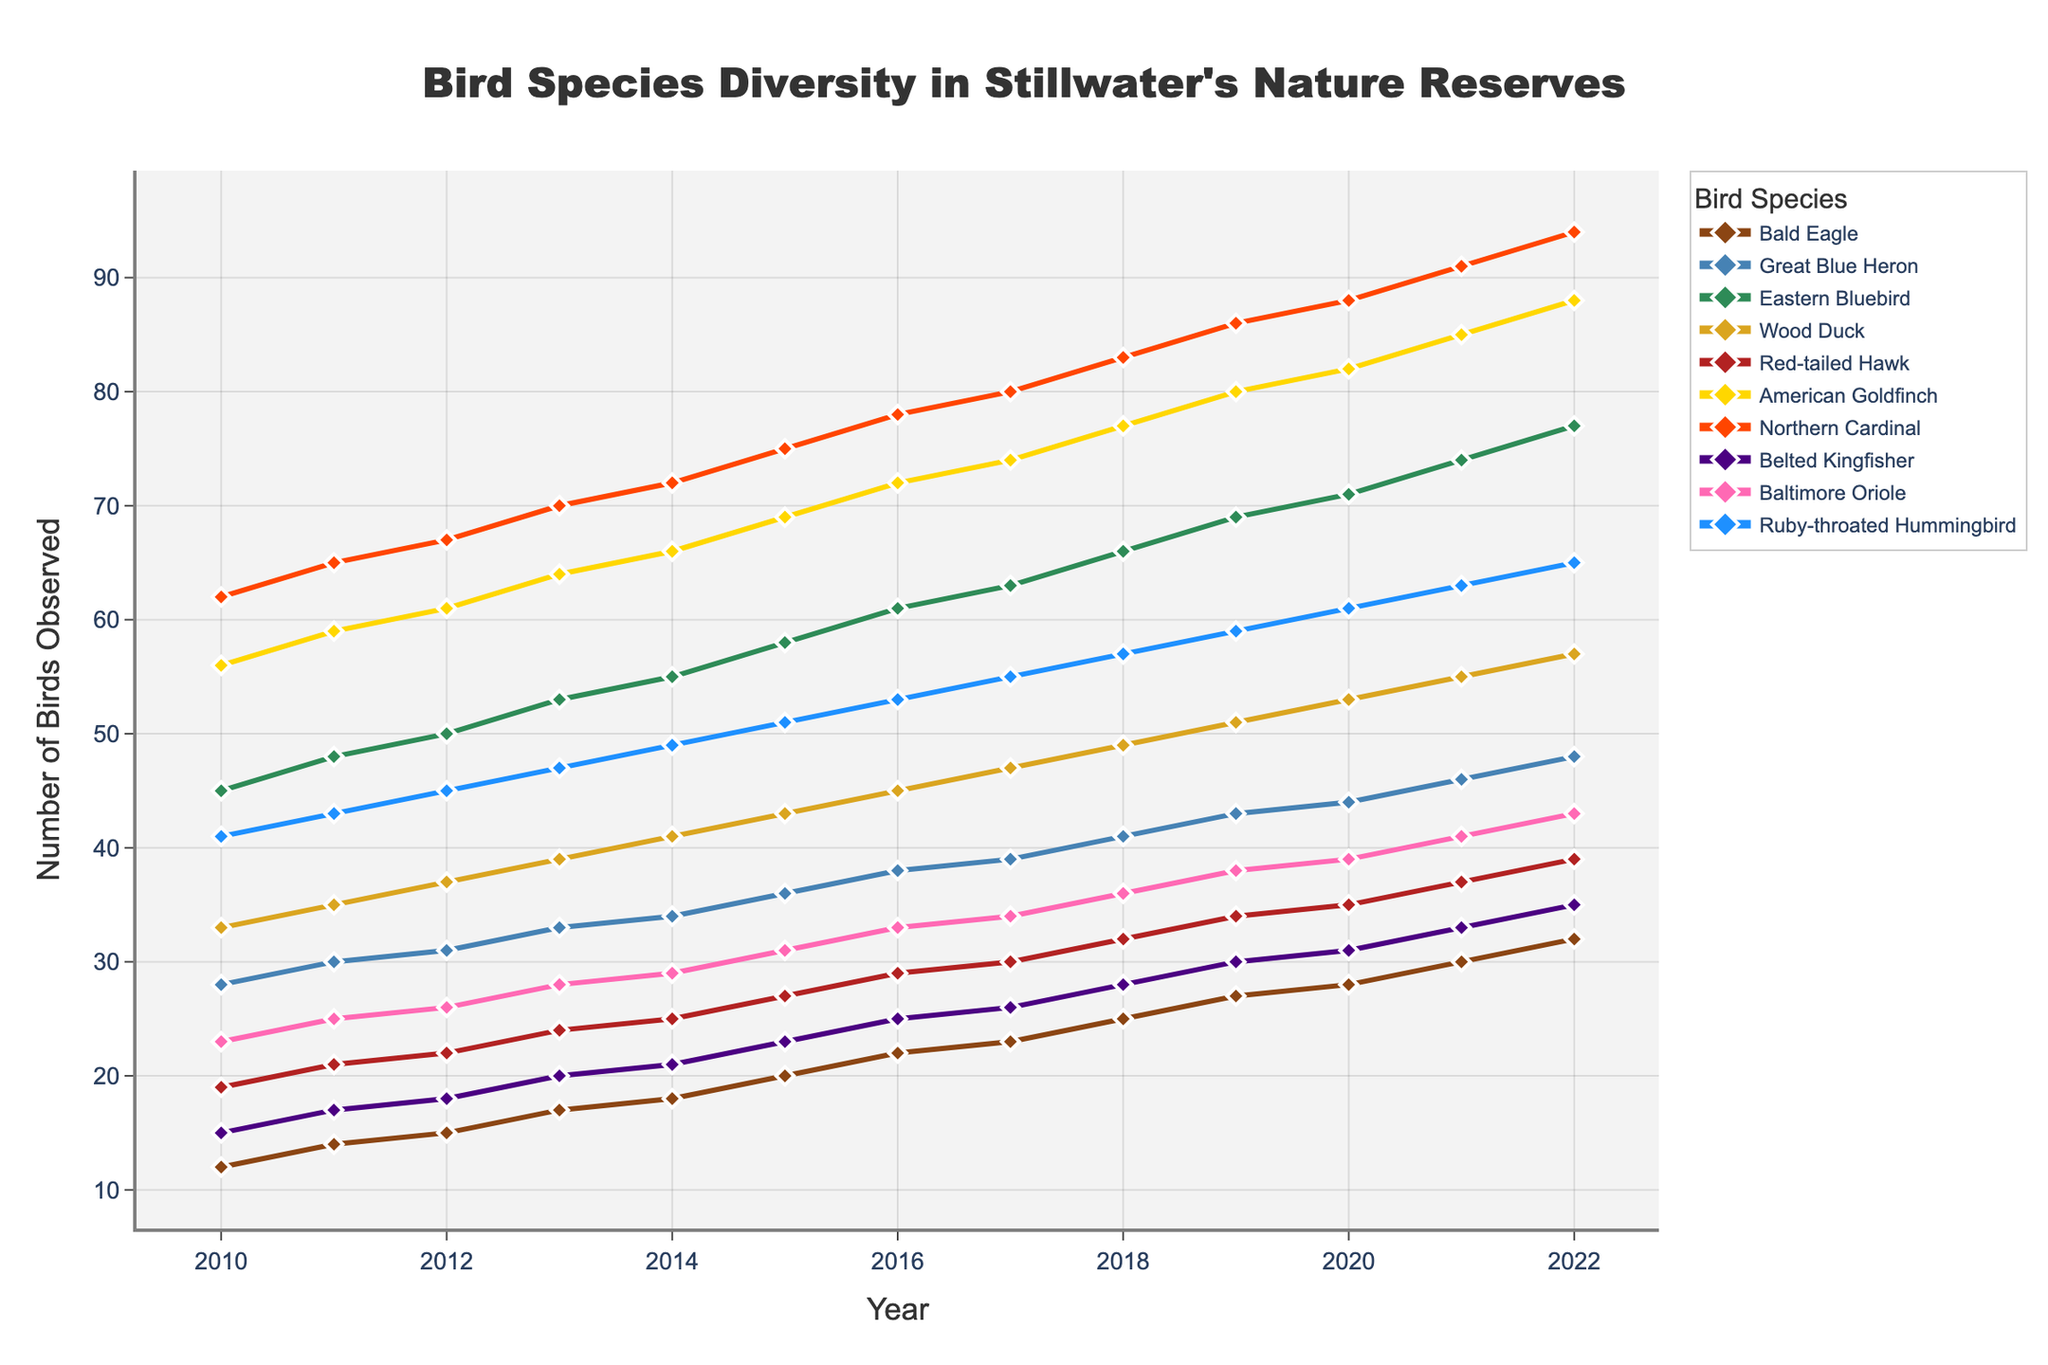What's the overall trend of Bald Eagle observations from 2010 to 2022? The line for Bald Eagles shows a consistent upward trend from 2010 (12 observations) to 2022 (32 observations), indicating an increase in their numbers each year.
Answer: Increasing How many species reached at least 80 observations by 2022? By 2022, the species with at least 80 observations are the American Goldfinch (88 observations), Northern Cardinal (94 observations), and Baltimore Oriole (84 observations).
Answer: 3 Which species had the largest increase in observations from 2010 to 2022? By calculating the difference between 2022 and 2010 for all species: Bald Eagle (20), Great Blue Heron (20), Eastern Bluebird (32), Wood Duck (24), Red-tailed Hawk (20), American Goldfinch (32), Northern Cardinal (32), Belted Kingfisher (20), Baltimore Oriole (20), Ruby-throated Hummingbird (24). The Eastern Bluebird, American Goldfinch, and Northern Cardinal had the largest increase at 32.
Answer: Eastern Bluebird, American Goldfinch, Northern Cardinal Which species had the fewest observations in 2010 and in 2022? In 2010, the Belted Kingfisher had the fewest observations with 15. In 2022, the Belted Kingfisher again had the fewest observations with 35.
Answer: Belted Kingfisher Which two species had similar numbers of observations in 2022? In 2022, Great Blue Heron (48) and Belted Kingfisher (35) were both relatively close in the middle range but not identical. However, Belted Kingfisher (35) and Ruby-throated Hummingbird (65) differ significantly. Upon closer inspection, no two species have almost identical observation counts in 2022.
Answer: None In what year did the American Goldfinch first reach 70 observations? The American Goldfinch reached 72 observations in 2016, the first year it crossed the 70 observations mark.
Answer: 2016 What is the median number of observations for the Great Blue Heron over the 13 years? To find the median, order the annual observations: 28, 30, 31, 33, 34, 36, 38, 39, 41, 43, 44, 46, 48. The middle value in this ordered list is 38.
Answer: 38 